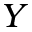Convert formula to latex. <formula><loc_0><loc_0><loc_500><loc_500>Y</formula> 